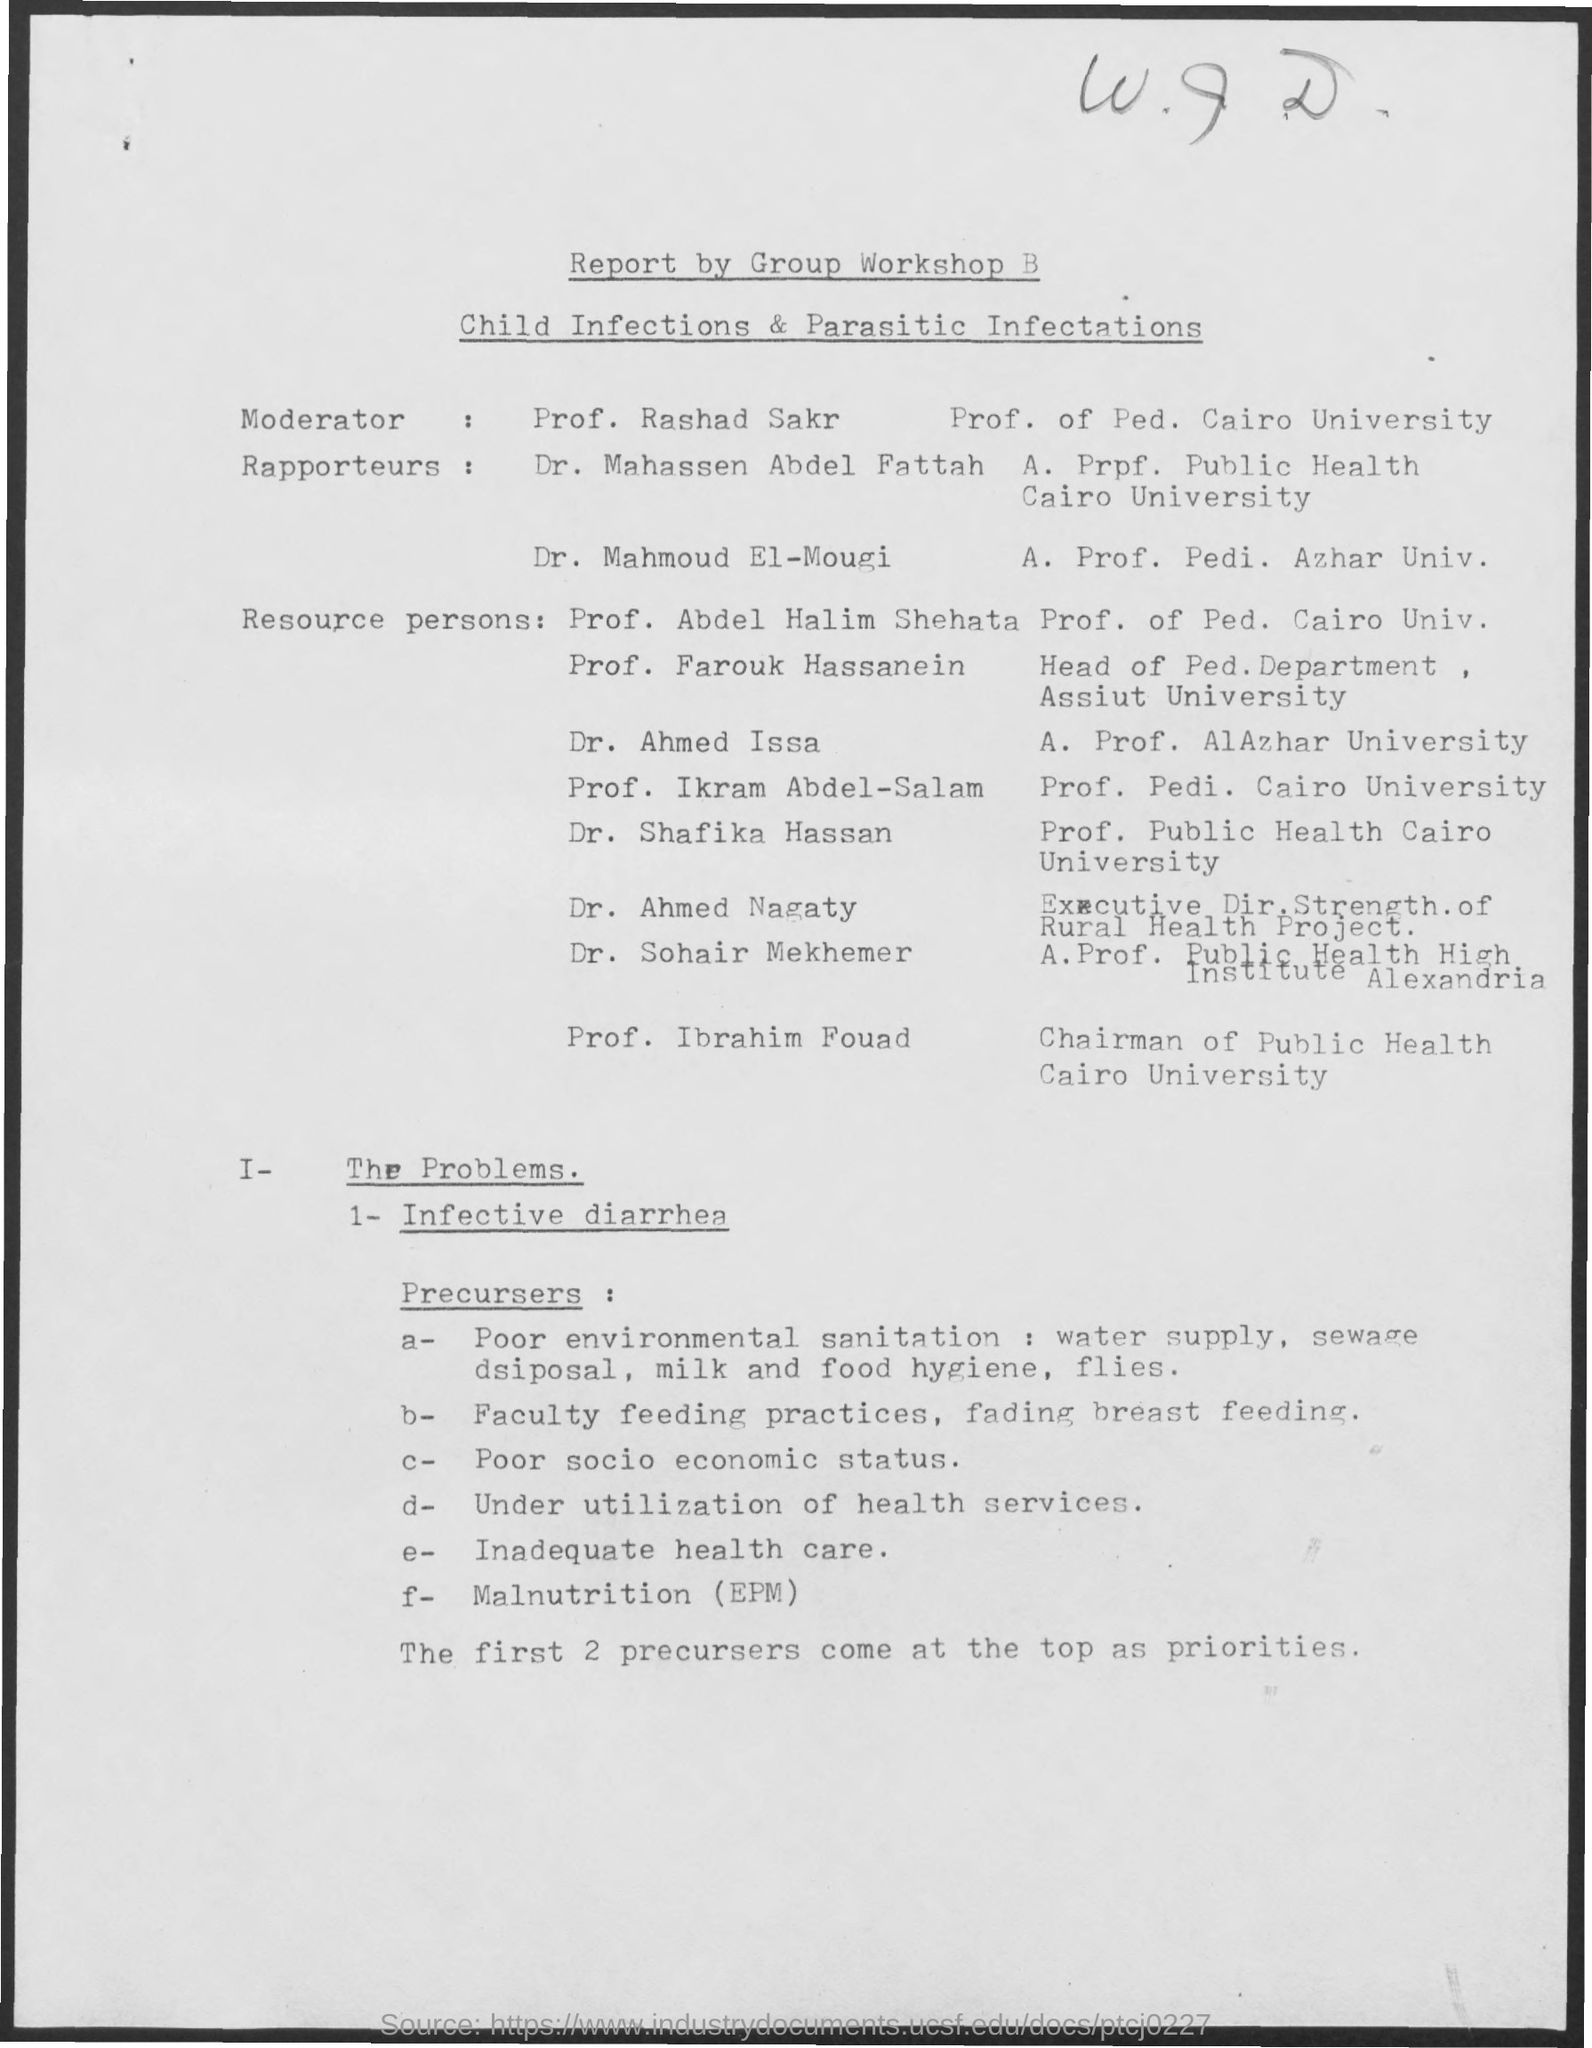Who is the Moderator?
Give a very brief answer. Prof. rashad sakr. 